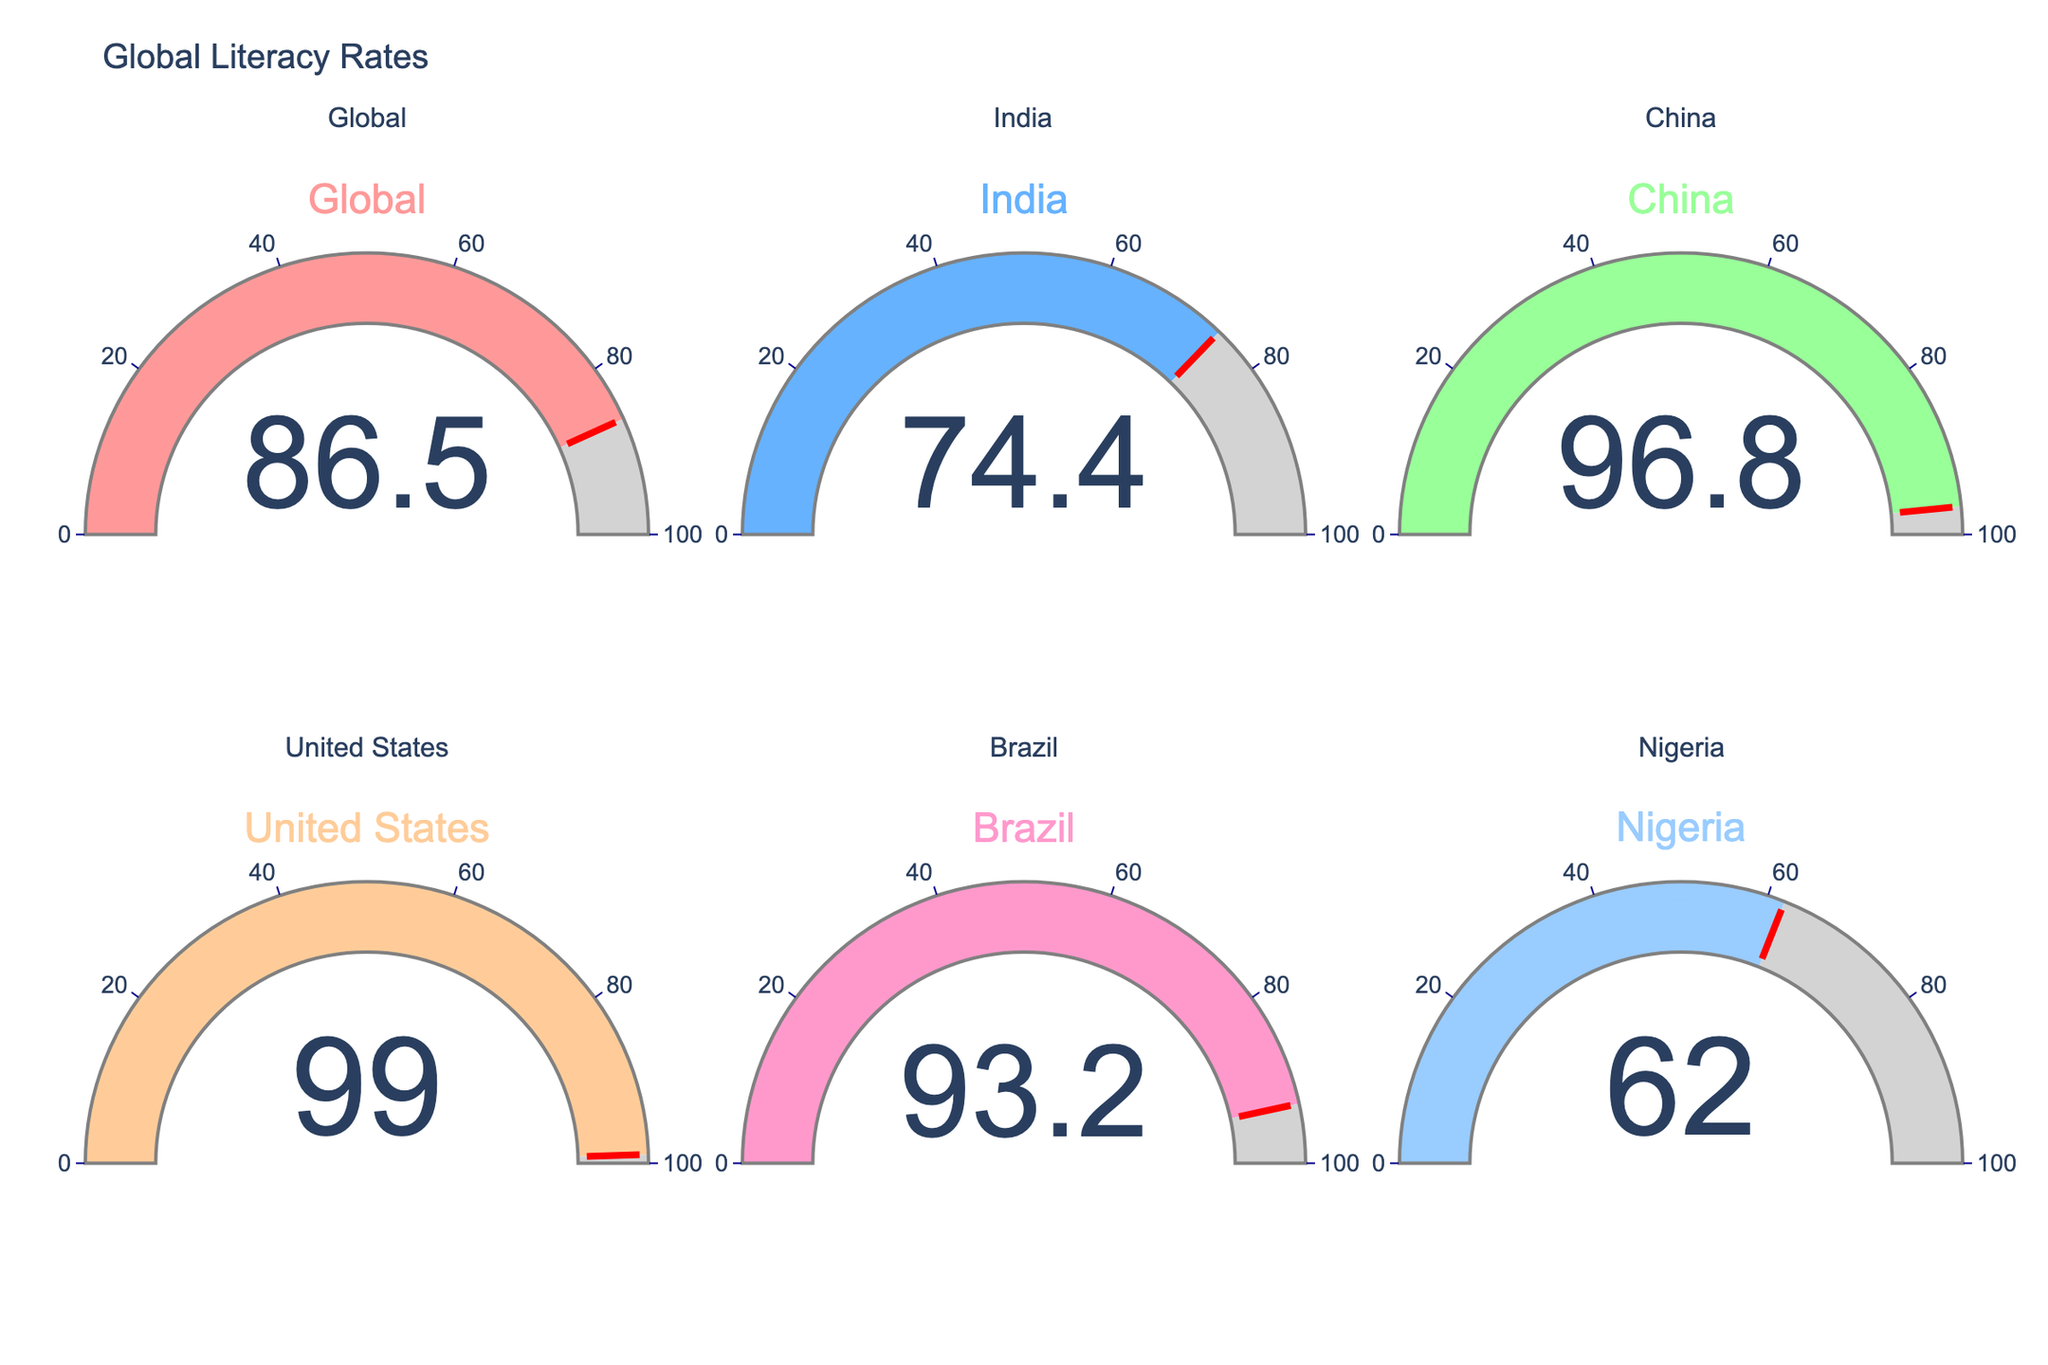What's the title of the figure? The title of a figure is usually displayed at the top of the chart, it reads "Global Literacy Rates".
Answer: Global Literacy Rates How many countries' literacy rates are displayed in the figure? Each gauge represents a country, and by counting the number of gauges in the chart, there are six total.
Answer: 6 What is the literacy rate of China? The gauge corresponding to China shows the literacy rate. On the gauge, it is indicated as 96.8.
Answer: 96.8 Which country has the highest literacy rate, and what is it? By comparing the values on all gauges, the United States has the highest literacy rate at 99.0.
Answer: United States, 99.0 Which country has the lowest literacy rate, and what is it? By comparing all the values, Nigeria has the lowest literacy rate at 62.0.
Answer: Nigeria, 62.0 What is the average literacy rate displayed in the figure? To find the average, sum all literacy rates and divide by the number of countries: (86.5 + 74.4 + 96.8 + 99.0 + 93.2 + 62.0) / 6 = 511.9 / 6 ≈ 85.32.
Answer: 85.32 How much higher is Brazil's literacy rate compared to Nigeria's? Subtract Nigeria's rate from Brazil's: 93.2 - 62.0 = 31.2.
Answer: 31.2 Which two countries have the closest literacy rates, and what are they? Comparing the absolute differences, Brazil (93.2) and China (96.8) have the closest rates:
Answer: Brazil and China, 93.2 and 96.8 Is the global literacy rate higher or lower than India's literacy rate? Comparing the global rate of 86.5 with India's rate of 74.4 shows that it is higher.
Answer: Higher What is the difference between the highest and lowest literacy rates in the figure? Subtract the lowest rate (Nigeria: 62.0) from the highest rate (United States: 99.0): 99.0 - 62.0 = 37.
Answer: 37 